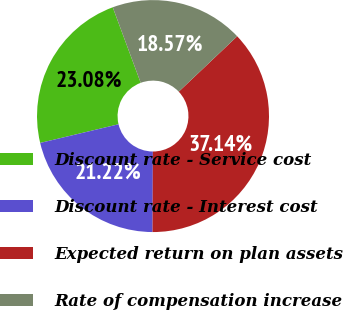Convert chart. <chart><loc_0><loc_0><loc_500><loc_500><pie_chart><fcel>Discount rate - Service cost<fcel>Discount rate - Interest cost<fcel>Expected return on plan assets<fcel>Rate of compensation increase<nl><fcel>23.08%<fcel>21.22%<fcel>37.14%<fcel>18.57%<nl></chart> 